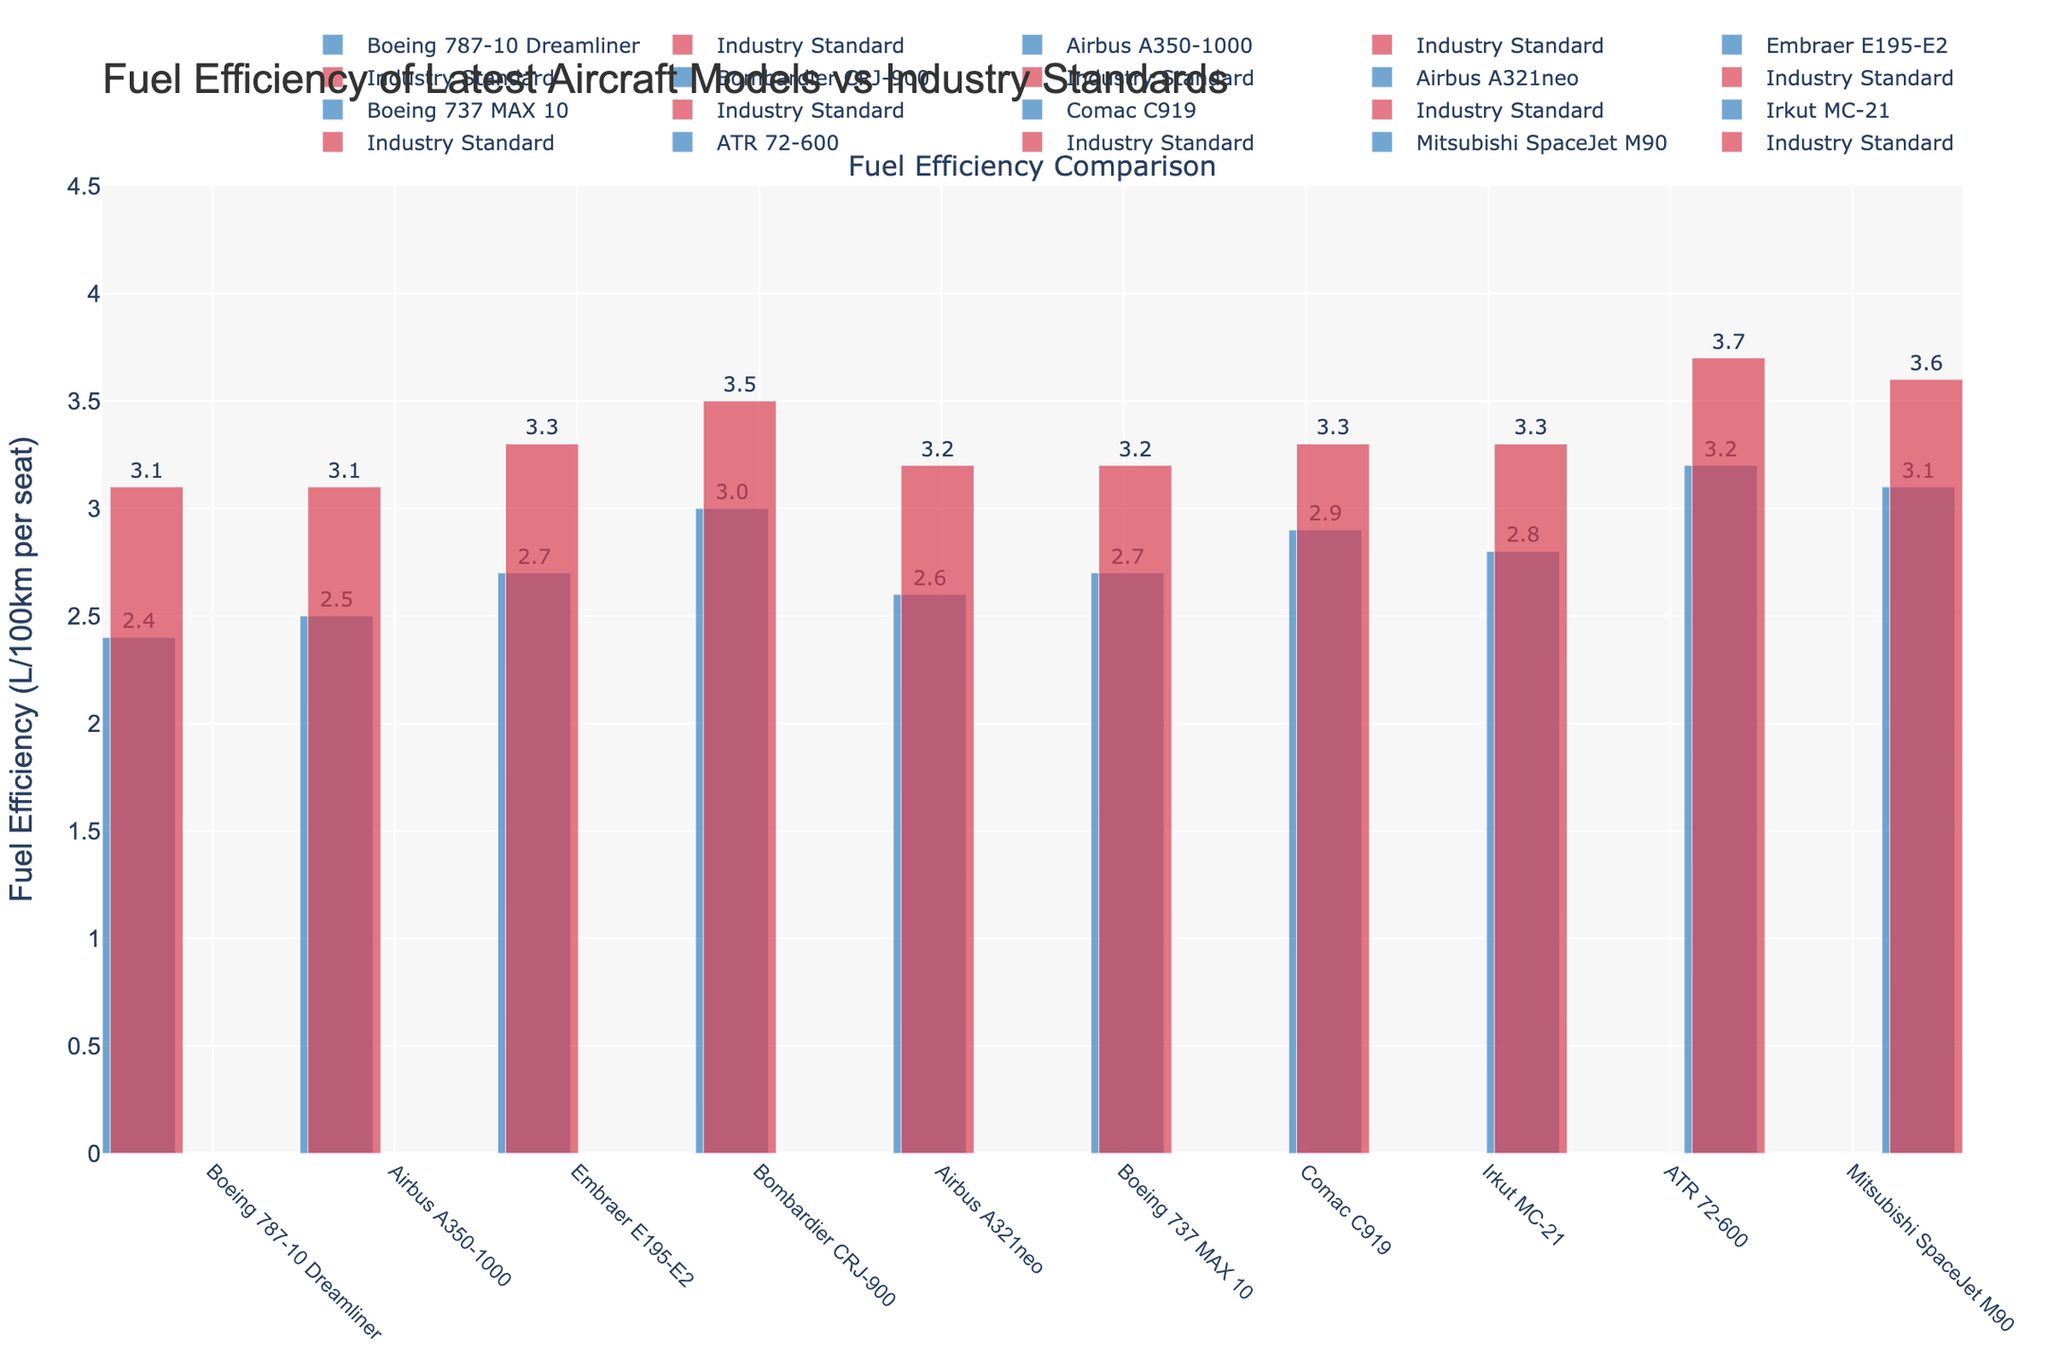What is the fuel efficiency of the Boeing 787-10 Dreamliner compared to the industry standard? The fuel efficiency of the Boeing 787-10 Dreamliner is 2.4 L/100km per seat, whereas the industry standard is 3.1 L/100km per seat.
Answer: Boeing 787-10 Dreamliner: 2.4 L/100km per seat, Industry Standard: 3.1 L/100km per seat How does the fuel efficiency of the Airbus A350-1000 compare to the Bombardier CRJ-900? The fuel efficiency of the Airbus A350-1000 is 2.5 L/100km per seat, while the Bombardier CRJ-900 is 3.0 L/100km per seat. The Airbus A350-1000 is more fuel-efficient.
Answer: Airbus A350-1000: 2.5 L/100km per seat, Bombardier CRJ-900: 3.0 L/100km per seat Which aircraft model has the least fuel efficiency compared to its industry standard? The ATR 72-600 has a fuel efficiency of 3.2 L/100km per seat, while its industry standard is 3.7 L/100km per seat, making the difference 0.5. No other model has a greater difference.
Answer: ATR 72-600 By how much does the Airbus A321neo's fuel efficiency exceed the industry standard? The fuel efficiency of the Airbus A321neo is 2.6 L/100km per seat, while the industry standard is 3.2 L/100km per seat. The difference is 3.2 - 2.6 = 0.6.
Answer: 0.6 L/100km per seat What is the average fuel efficiency of the aircraft models excluding the industry standard? Sum the fuel efficiency of all aircraft models: 2.4 + 2.5 + 2.7 + 3.0 + 2.6 + 2.7 + 2.9 + 2.8 + 3.2 + 3.1 = 28.9. There are 10 models, so the average is 28.9 / 10 = 2.89.
Answer: 2.89 L/100km per seat Which aircraft models exceed their industry's standard fuel efficiency by more than 0.5 L/100km per seat? Comparing the values, Airbus A350-1000 (0.6), Embraer E195-E2 (0.6), and Airbus A321neo (0.6) exceed the industry standard by 0.6 each.
Answer: Airbus A350-1000, Embraer E195-E2, Airbus A321neo What is the difference in fuel efficiency between the most and least efficient aircraft models? The most efficient model is Boeing 787-10 Dreamliner at 2.4 L/100km per seat, and the least efficient is ATR 72-600 at 3.2 L/100km per seat. The difference is 3.2 - 2.4 = 0.8.
Answer: 0.8 L/100km per seat How many aircraft models have better fuel efficiency than the industry standard of 3.1 L/100km per seat? The models that are more efficient than 3.1 L/100km per seat are Boeing 787-10 Dreamliner, Airbus A350-1000, Embraer E195-E2, Airbus A321neo, Boeing 737 MAX 10, Comac C919, and Irkut MC-21. This totals 7 models.
Answer: 7 models Which color represents the fuel efficiency of individual aircraft models in the bar chart? The individual aircraft models' fuel efficiencies are represented by blue bars.
Answer: Blue What visual attribute indicates the industry standard fuel efficiency in the bar chart? The industry standard fuel efficiencies are indicated by red bars.
Answer: Red 